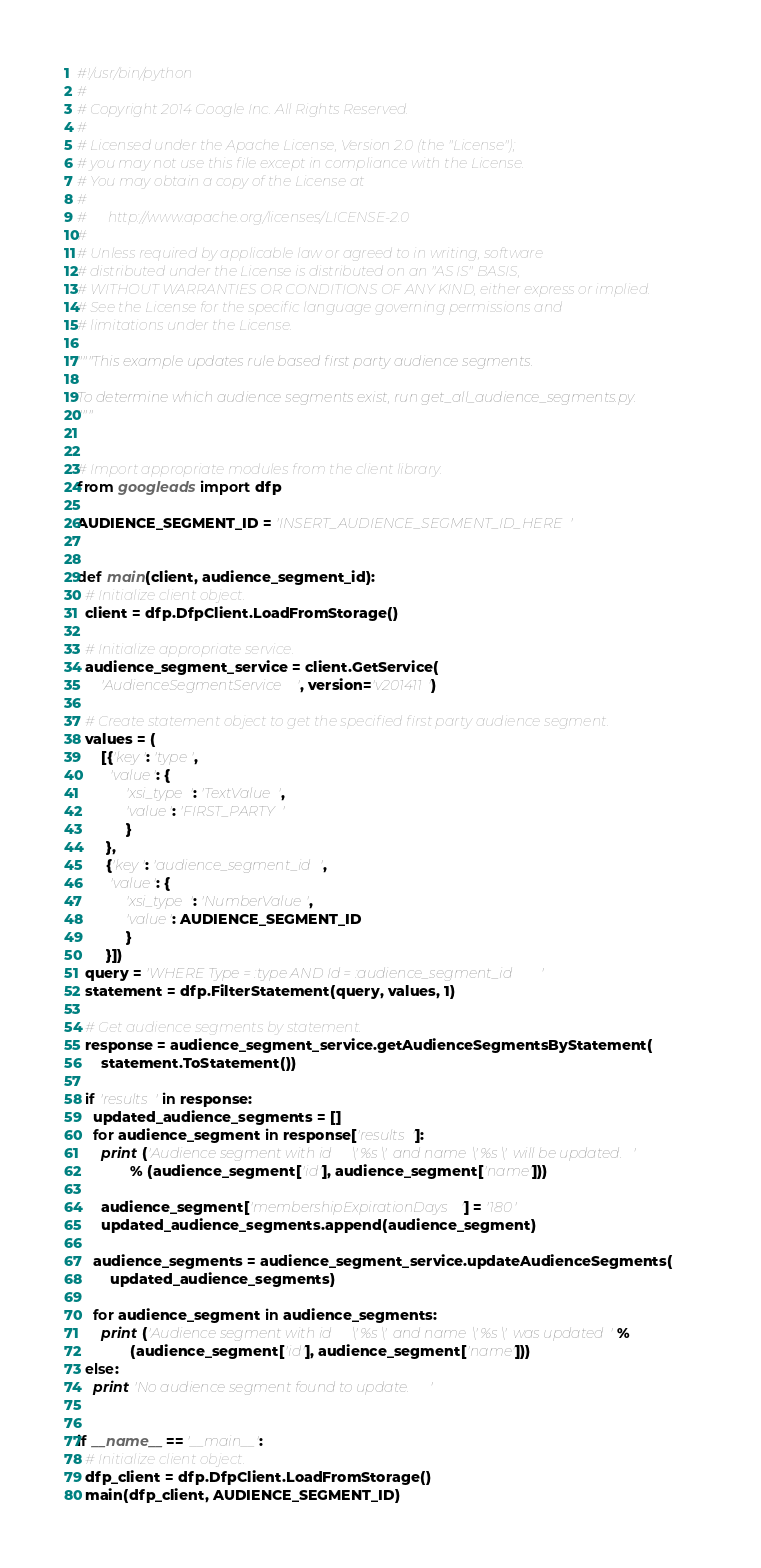Convert code to text. <code><loc_0><loc_0><loc_500><loc_500><_Python_>#!/usr/bin/python
#
# Copyright 2014 Google Inc. All Rights Reserved.
#
# Licensed under the Apache License, Version 2.0 (the "License");
# you may not use this file except in compliance with the License.
# You may obtain a copy of the License at
#
#      http://www.apache.org/licenses/LICENSE-2.0
#
# Unless required by applicable law or agreed to in writing, software
# distributed under the License is distributed on an "AS IS" BASIS,
# WITHOUT WARRANTIES OR CONDITIONS OF ANY KIND, either express or implied.
# See the License for the specific language governing permissions and
# limitations under the License.

"""This example updates rule based first party audience segments.

To determine which audience segments exist, run get_all_audience_segments.py.
"""


# Import appropriate modules from the client library.
from googleads import dfp

AUDIENCE_SEGMENT_ID = 'INSERT_AUDIENCE_SEGMENT_ID_HERE'


def main(client, audience_segment_id):
  # Initialize client object.
  client = dfp.DfpClient.LoadFromStorage()

  # Initialize appropriate service.
  audience_segment_service = client.GetService(
      'AudienceSegmentService', version='v201411')

  # Create statement object to get the specified first party audience segment.
  values = (
      [{'key': 'type',
        'value': {
            'xsi_type': 'TextValue',
            'value': 'FIRST_PARTY'
            }
       },
       {'key': 'audience_segment_id',
        'value': {
            'xsi_type': 'NumberValue',
            'value': AUDIENCE_SEGMENT_ID
            }
       }])
  query = 'WHERE Type = :type AND Id = :audience_segment_id'
  statement = dfp.FilterStatement(query, values, 1)

  # Get audience segments by statement.
  response = audience_segment_service.getAudienceSegmentsByStatement(
      statement.ToStatement())

  if 'results' in response:
    updated_audience_segments = []
    for audience_segment in response['results']:
      print ('Audience segment with id \'%s\' and name \'%s\' will be updated.'
             % (audience_segment['id'], audience_segment['name']))

      audience_segment['membershipExpirationDays'] = '180'
      updated_audience_segments.append(audience_segment)

    audience_segments = audience_segment_service.updateAudienceSegments(
        updated_audience_segments)

    for audience_segment in audience_segments:
      print ('Audience segment with id \'%s\' and name \'%s\' was updated' %
             (audience_segment['id'], audience_segment['name']))
  else:
    print 'No audience segment found to update.'


if __name__ == '__main__':
  # Initialize client object.
  dfp_client = dfp.DfpClient.LoadFromStorage()
  main(dfp_client, AUDIENCE_SEGMENT_ID)
</code> 